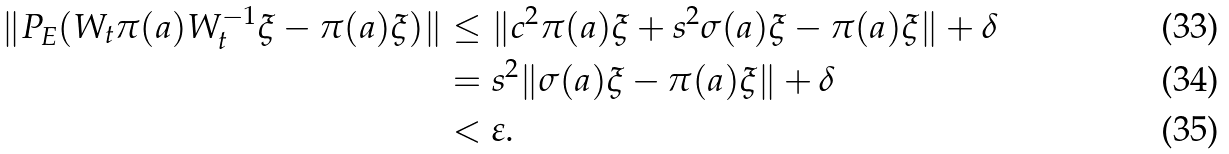Convert formula to latex. <formula><loc_0><loc_0><loc_500><loc_500>\| P _ { E } ( W _ { t } \pi ( a ) W _ { t } ^ { - 1 } \xi - \pi ( a ) \xi ) \| & \leq \| c ^ { 2 } \pi ( a ) \xi + s ^ { 2 } \sigma ( a ) \xi - \pi ( a ) \xi \| + \delta \\ & = s ^ { 2 } \| \sigma ( a ) \xi - \pi ( a ) \xi \| + \delta \\ & < \varepsilon .</formula> 